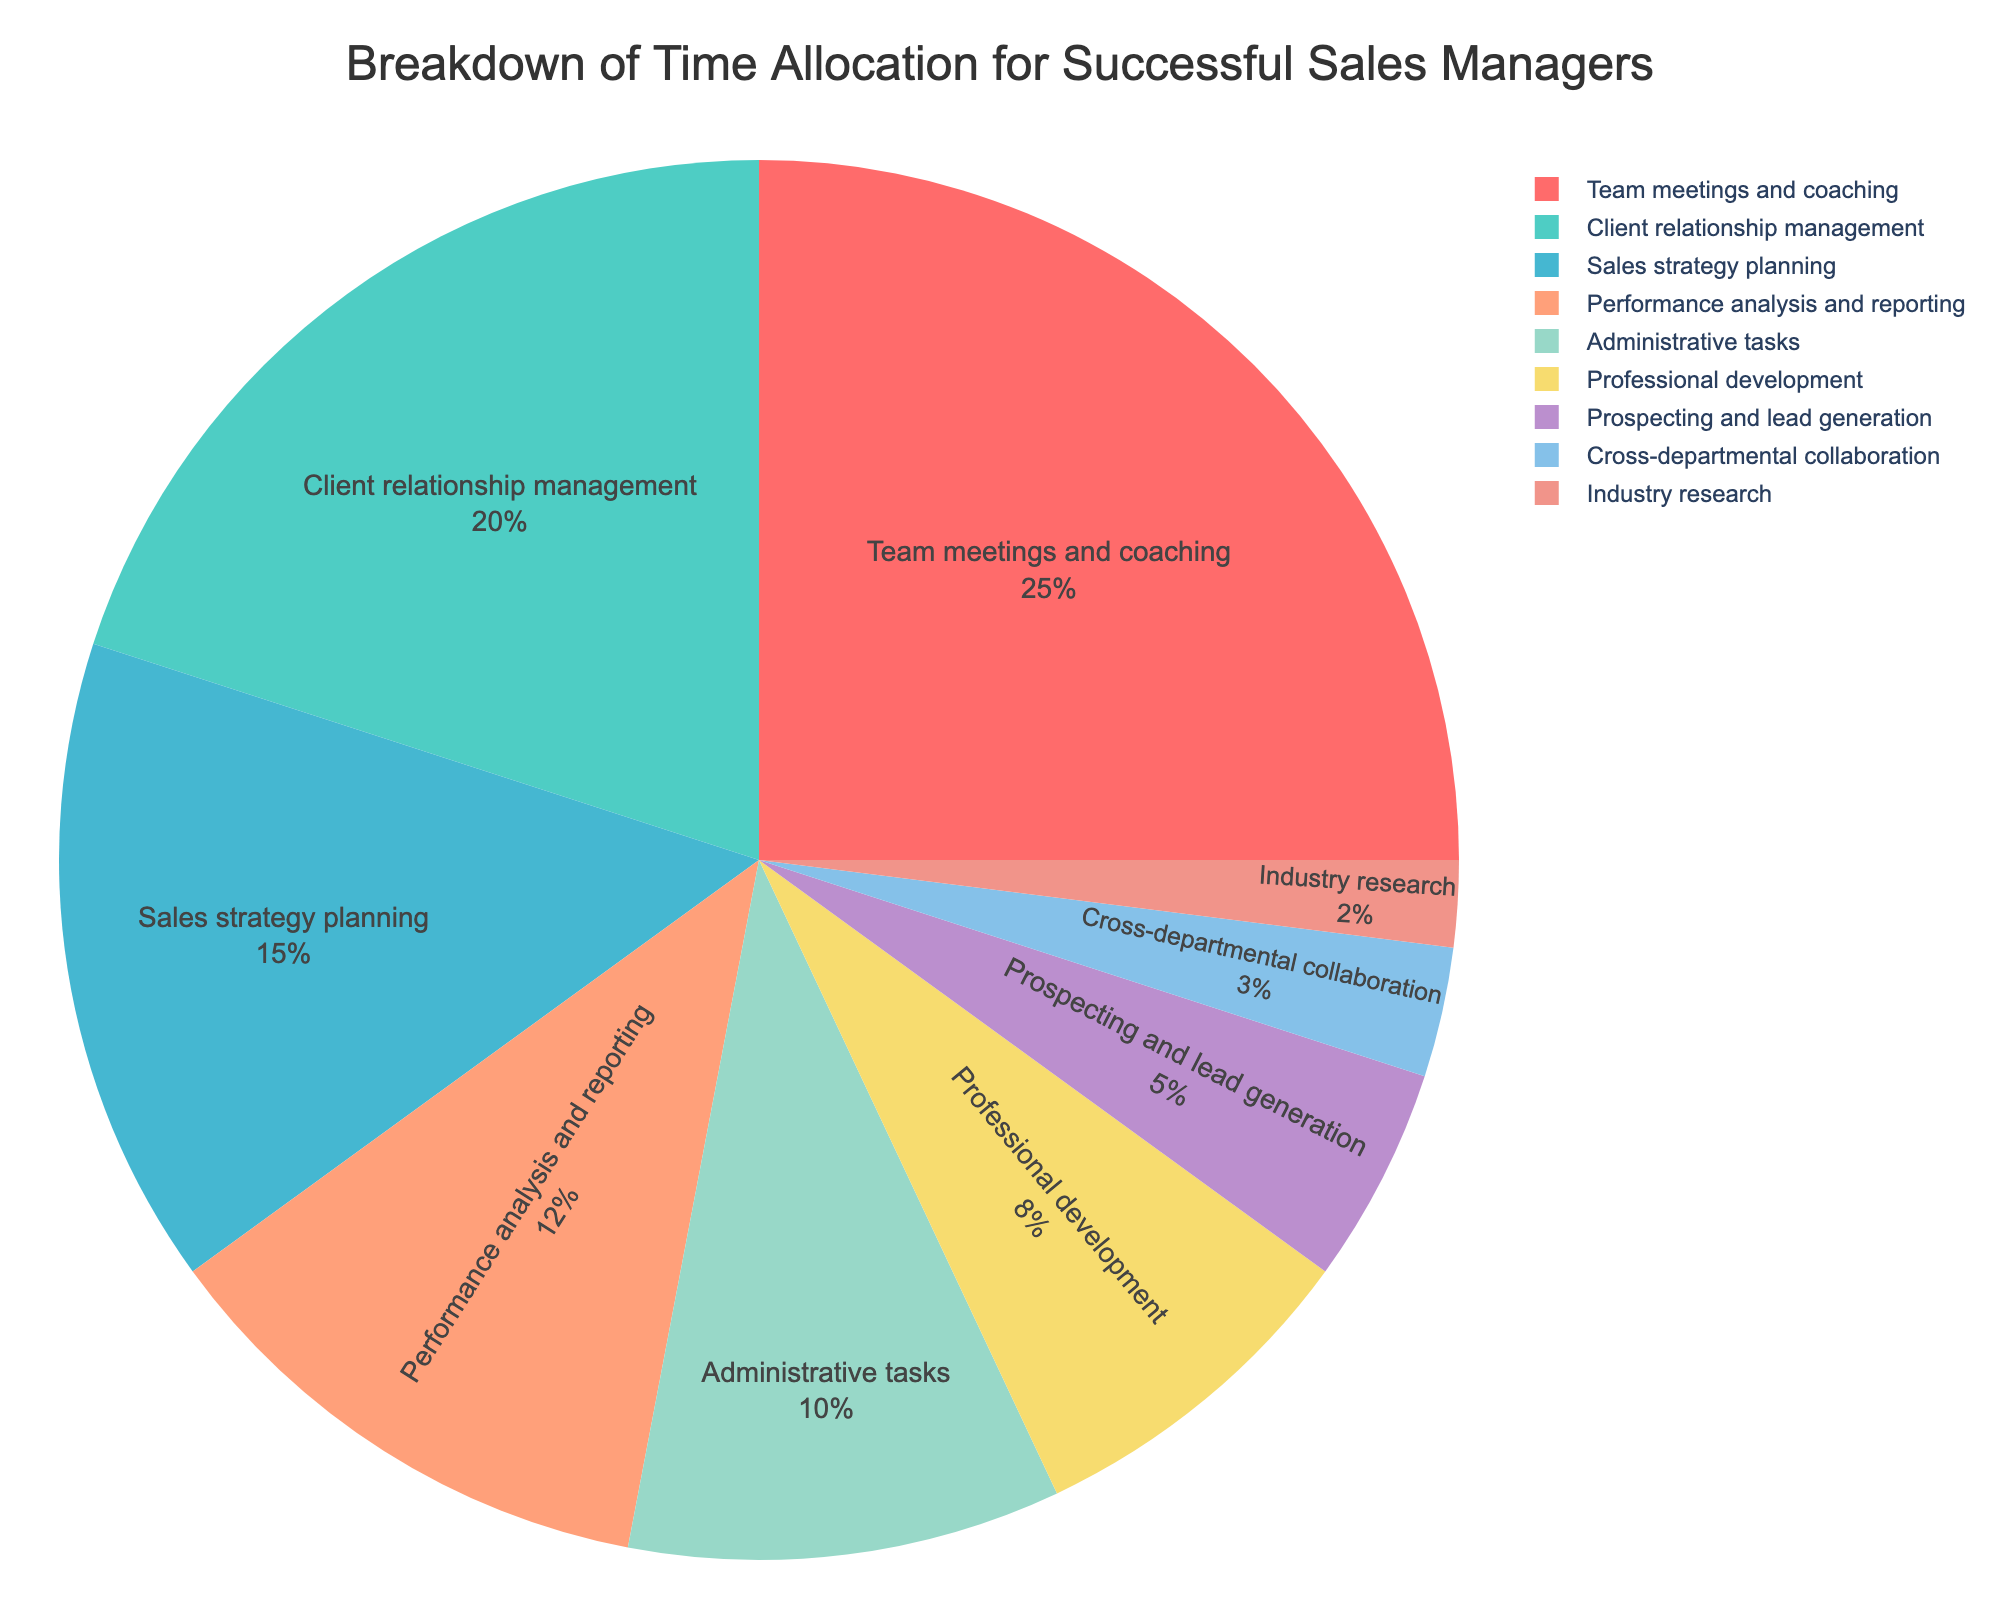What's the largest time allocation activity for successful sales managers? The largest time allocation activity is the one with the highest percentage. Referring to the pie chart, "Team meetings and coaching" has the highest percentage at 25%.
Answer: Team meetings and coaching What is the combined percentage of activities related to client interactions? First, identify activities related to client interactions: "Client relationship management" (20%) and "Prospecting and lead generation" (5%). Sum their percentages: 20% + 5% = 25%.
Answer: 25% Which activity has a smaller allocation than Professional development but greater than Cross-departmental collaboration? Professional development is allotted 8%, and Cross-departmental collaboration is 3%. The activity with a percentage between these values is "Prospecting and lead generation" with 5%.
Answer: Prospecting and lead generation How much time do successful sales managers allocate to activities not directly related to sales? Identify activities not directly related to sales: "Administrative tasks" (10%), "Professional development" (8%), "Cross-departmental collaboration" (3%), and "Industry research" (2%). Total their percentages: 10% + 8% + 3% + 2% = 23%.
Answer: 23% Is the percentage of time spent on Sales strategy planning higher or lower than Client relationship management? Compare their percentages: "Sales strategy planning" is 15%, while "Client relationship management" is 20%. Therefore, Sales strategy planning is lower.
Answer: Lower What is the difference in the percentage of time spent on Performance analysis and reporting versus Administrative tasks? Find the percentages: "Performance analysis and reporting" is 12% and "Administrative tasks" is 10%. Subtract the smaller from the larger: 12% - 10% = 2%.
Answer: 2% Which activity occupies the smallest percentage of the time allocation? Identify the activity with the smallest percentage in the pie chart. "Industry research" is the smallest with 2%.
Answer: Industry research What percentage of time do successful sales managers spend on strategic planning activities? "Sales strategy planning" is the only activity related to strategic planning with a percentage of 15%.
Answer: 15% Are there more activities with a percentage equal to or greater than 10% or those with less than 10%? Activities with ≥10% are: "Team meetings and coaching" (25%), "Client relationship management" (20%), "Sales strategy planning" (15%), "Performance analysis and reporting" (12%), "Administrative tasks" (10%) — total: 5. Activities with <10% are: "Professional development" (8%), "Prospecting and lead generation" (5%), "Cross-departmental collaboration" (3%), "Industry research" (2%) — total: 4. There are more activities with percentages ≥10%.
Answer: Equal to or greater than 10% What color represents Sales strategy planning on the pie chart? Referring to the color legend in the pie chart, "Sales strategy planning" is represented by the third color which is a bluish shade.
Answer: Blue 